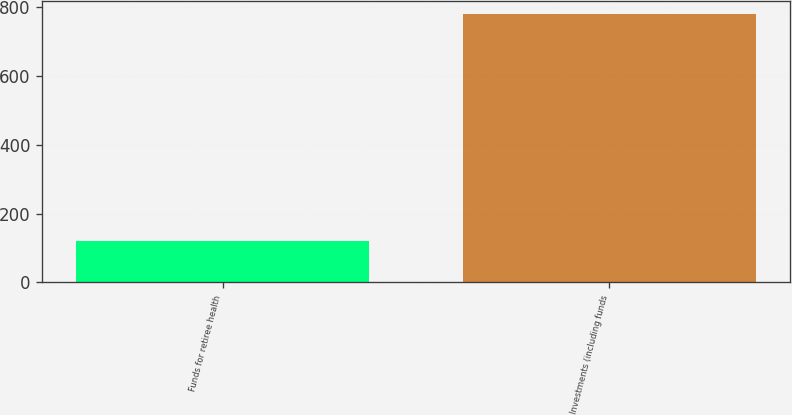Convert chart. <chart><loc_0><loc_0><loc_500><loc_500><bar_chart><fcel>Funds for retiree health<fcel>Investments (including funds<nl><fcel>120<fcel>780<nl></chart> 